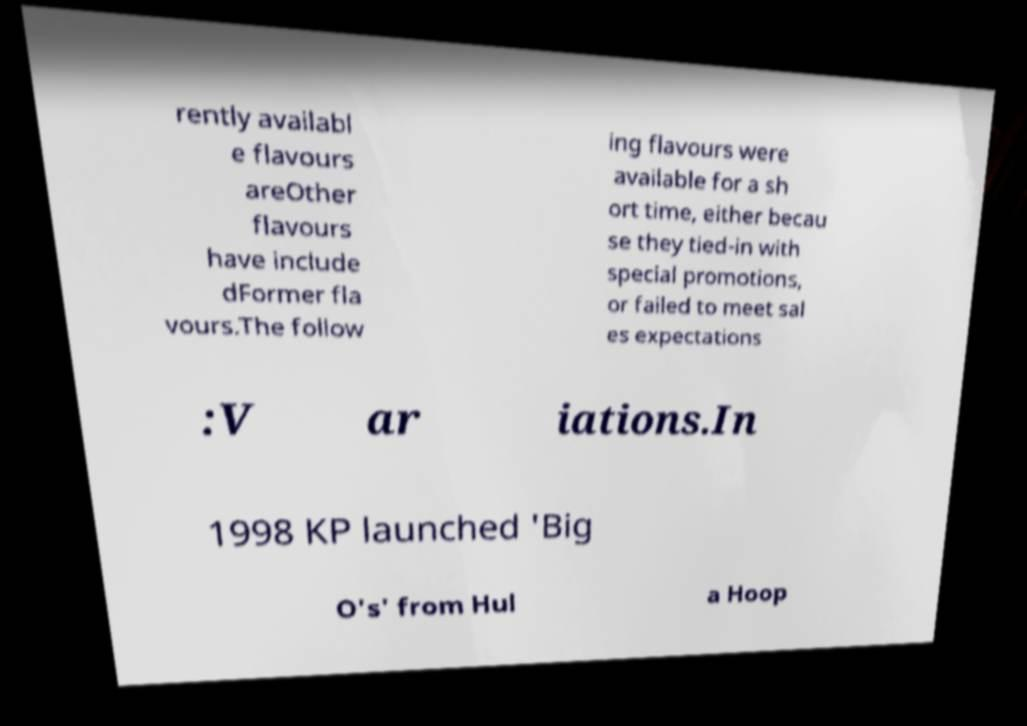For documentation purposes, I need the text within this image transcribed. Could you provide that? rently availabl e flavours areOther flavours have include dFormer fla vours.The follow ing flavours were available for a sh ort time, either becau se they tied-in with special promotions, or failed to meet sal es expectations :V ar iations.In 1998 KP launched 'Big O's' from Hul a Hoop 